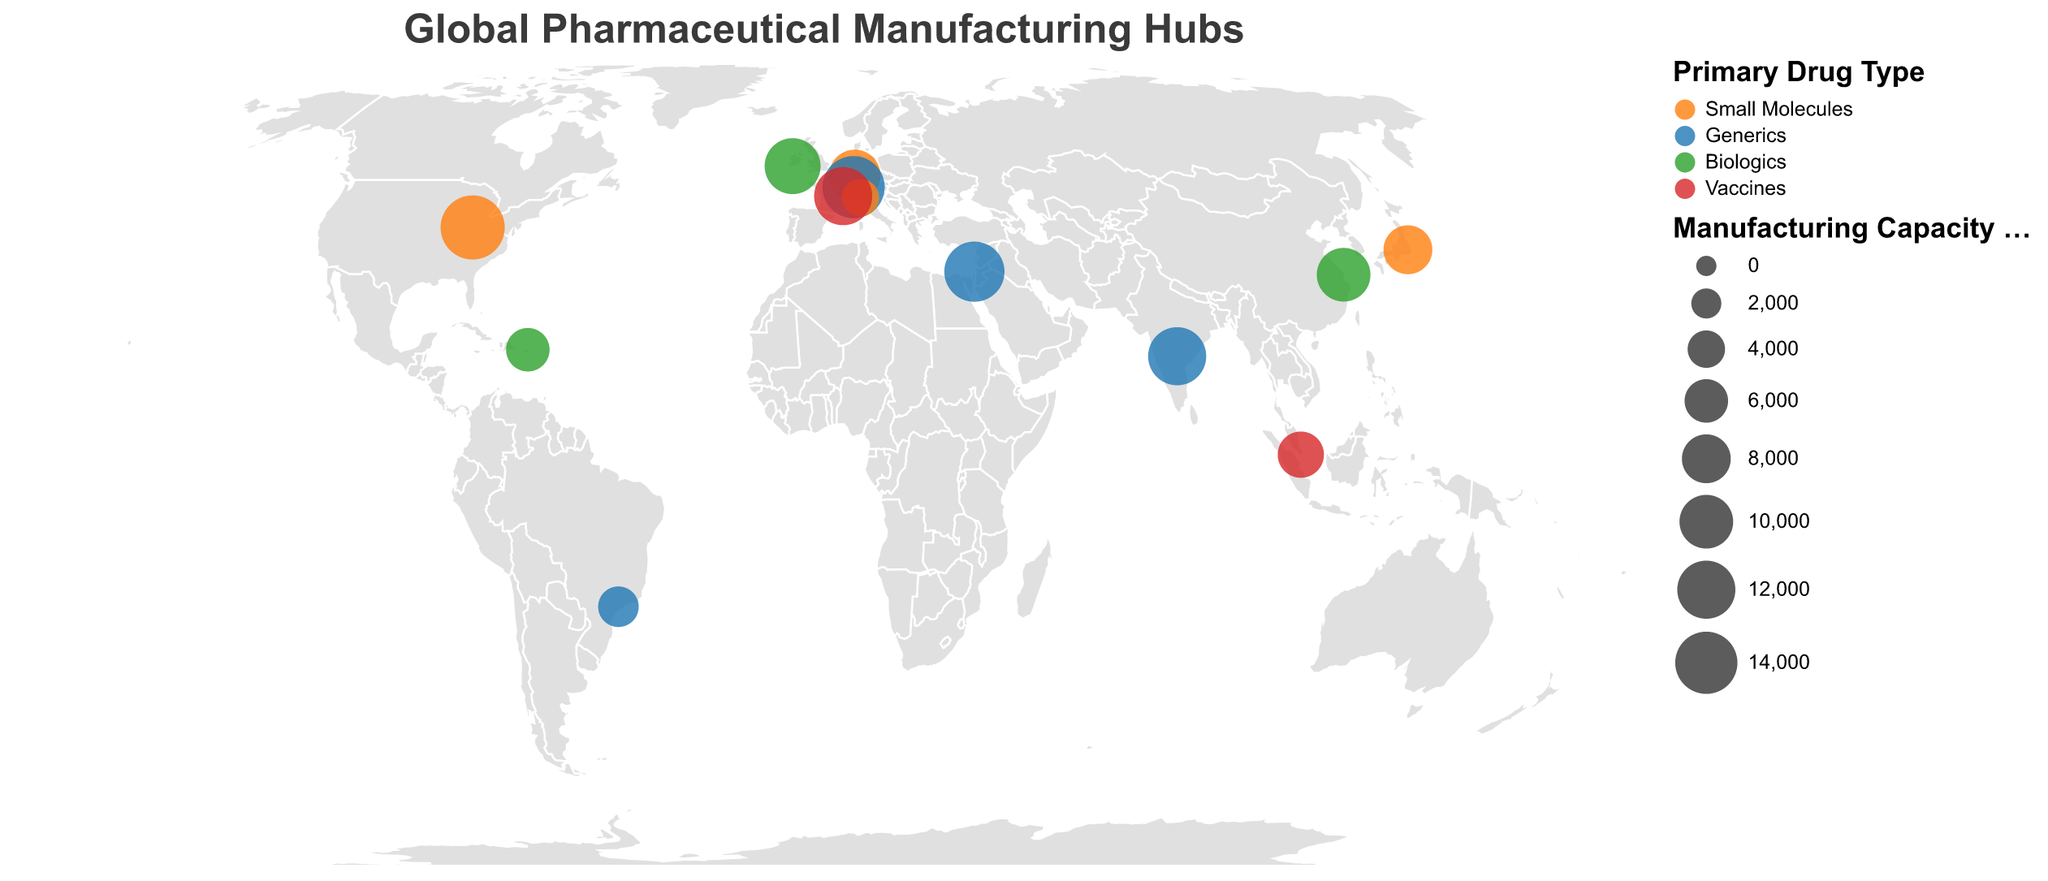What is the title of the figure? The title is prominently displayed at the top of the figure and describes the content of the geographic plot.
Answer: Global Pharmaceutical Manufacturing Hubs How many pharmaceutical manufacturing hubs are shown in the figure? By counting the number of data points (circles) on the map, we can determine the total number of hubs.
Answer: 13 Which company has the highest manufacturing capacity? By referring to the circle sizes and the tooltip information, we can see that Eli Lilly in the USA has the largest circle, indicating the highest manufacturing capacity.
Answer: Eli Lilly Which primary drug type is most common among the major hubs? By looking at the color legend and the map, we count how many circles correspond to each primary drug type. Generics have the most circles with 4 hubs (Hyderabad, Basel, Jerusalem, São Paulo).
Answer: Generics What is the combined manufacturing capacity of all hubs producing biologics? Adding the manufacturing capacities of WuXi AppTec, Pfizer, AbbVie totals 10000 + 11000 + 6000.
Answer: 27000 Which city, if any, has more than one company listed? By examining the cities listed in the data, each city corresponds to only one company location on the map.
Answer: None How much larger is Eli Lilly's manufacturing capacity compared to Menarini's? Subtract Menarini's capacity from Eli Lilly's capacity: 15000 - 4000.
Answer: 11000 Which company specializes in vaccines and has the highest manufacturing capacity in that category? By filtering the data to only those producing vaccines and comparing their capacities, Sanofi in Lyon has the highest with 12000 tons/year.
Answer: Sanofi What is the smallest manufacturing hub in terms of capacity, and what drug type do they produce? Finding the smallest circle on the map and referring to the tooltip data, Menarini in Milan has the smallest capacity, producing Small Molecules.
Answer: Menarini, Small Molecules How many continents are represented in the pharmaceutical manufacturing hubs? By identifying the continents from the countries listed, we have North America, South America, Europe, Asia, and Australia (Singapore).
Answer: 5 